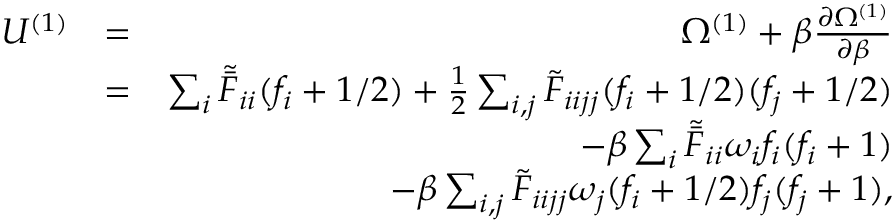Convert formula to latex. <formula><loc_0><loc_0><loc_500><loc_500>\begin{array} { r l r } { U ^ { ( 1 ) } } & { = } & { \Omega ^ { ( 1 ) } + \beta \frac { \partial \Omega ^ { ( 1 ) } } { \partial \beta } } \\ & { = } & { \sum _ { i } \tilde { \bar { F } } _ { i i } { ( f _ { i } + 1 / 2 ) } + \frac { 1 } { 2 } \sum _ { i , j } \tilde { F } _ { i i j j } ( f _ { i } + 1 / 2 ) ( f _ { j } + 1 / 2 ) } \\ & { - { \beta } \sum _ { i } \tilde { \bar { F } } _ { i i } \omega _ { i } f _ { i } ( f _ { i } + 1 ) } \\ & { - { \beta } \sum _ { i , j } \tilde { F } _ { i i j j } \omega _ { j } ( f _ { i } + 1 / 2 ) f _ { j } ( f _ { j } + 1 ) , } \end{array}</formula> 